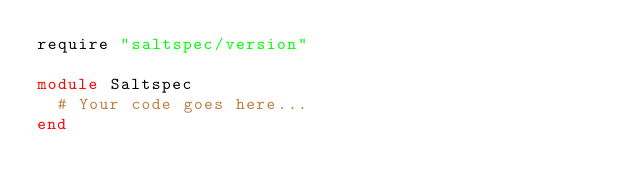Convert code to text. <code><loc_0><loc_0><loc_500><loc_500><_Ruby_>require "saltspec/version"

module Saltspec
  # Your code goes here...
end
</code> 